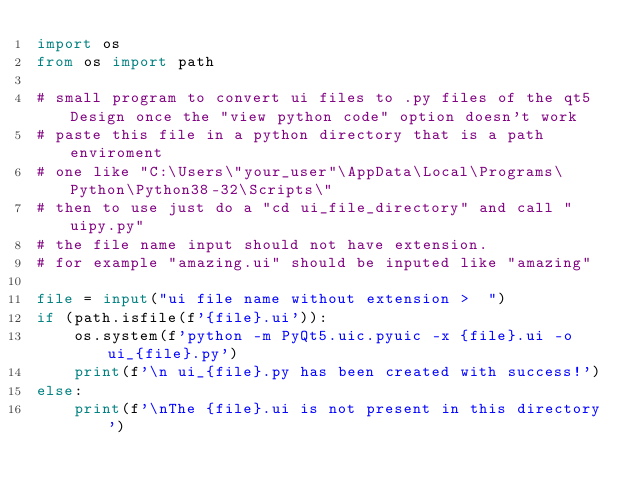Convert code to text. <code><loc_0><loc_0><loc_500><loc_500><_Python_>import os
from os import path

# small program to convert ui files to .py files of the qt5 Design once the "view python code" option doesn't work
# paste this file in a python directory that is a path enviroment
# one like "C:\Users\"your_user"\AppData\Local\Programs\Python\Python38-32\Scripts\"
# then to use just do a "cd ui_file_directory" and call "uipy.py"
# the file name input should not have extension.
# for example "amazing.ui" should be inputed like "amazing"

file = input("ui file name without extension >  ")
if (path.isfile(f'{file}.ui')):
    os.system(f'python -m PyQt5.uic.pyuic -x {file}.ui -o ui_{file}.py')
    print(f'\n ui_{file}.py has been created with success!')
else:
    print(f'\nThe {file}.ui is not present in this directory')
</code> 